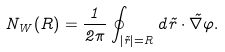Convert formula to latex. <formula><loc_0><loc_0><loc_500><loc_500>N _ { W } ( R ) = \frac { 1 } { 2 \pi } \oint _ { | \vec { r } | = R } d \vec { r } \cdot \vec { \nabla } \varphi .</formula> 